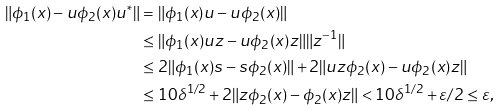<formula> <loc_0><loc_0><loc_500><loc_500>\| \phi _ { 1 } ( x ) - u \phi _ { 2 } ( x ) u ^ { * } \| & = \| \phi _ { 1 } ( x ) u - u \phi _ { 2 } ( x ) \| \\ & \leq \| \phi _ { 1 } ( x ) u z - u \phi _ { 2 } ( x ) z \| \| z ^ { - 1 } \| \\ & \leq 2 \| \phi _ { 1 } ( x ) s - s \phi _ { 2 } ( x ) \| + 2 \| u z \phi _ { 2 } ( x ) - u \phi _ { 2 } ( x ) z \| \\ & \leq 1 0 \delta ^ { 1 / 2 } + 2 \| z \phi _ { 2 } ( x ) - \phi _ { 2 } ( x ) z \| < 1 0 \delta ^ { 1 / 2 } + \varepsilon / 2 \leq \varepsilon ,</formula> 